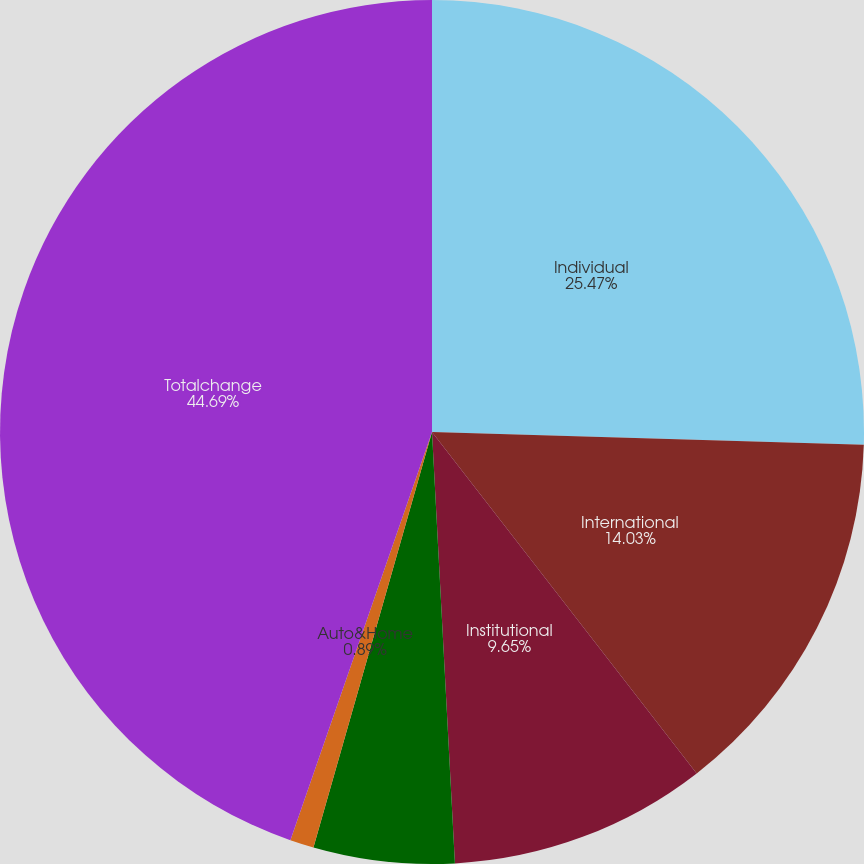Convert chart. <chart><loc_0><loc_0><loc_500><loc_500><pie_chart><fcel>Individual<fcel>International<fcel>Institutional<fcel>Corporate&Other<fcel>Auto&Home<fcel>Totalchange<nl><fcel>25.47%<fcel>14.03%<fcel>9.65%<fcel>5.27%<fcel>0.89%<fcel>44.68%<nl></chart> 